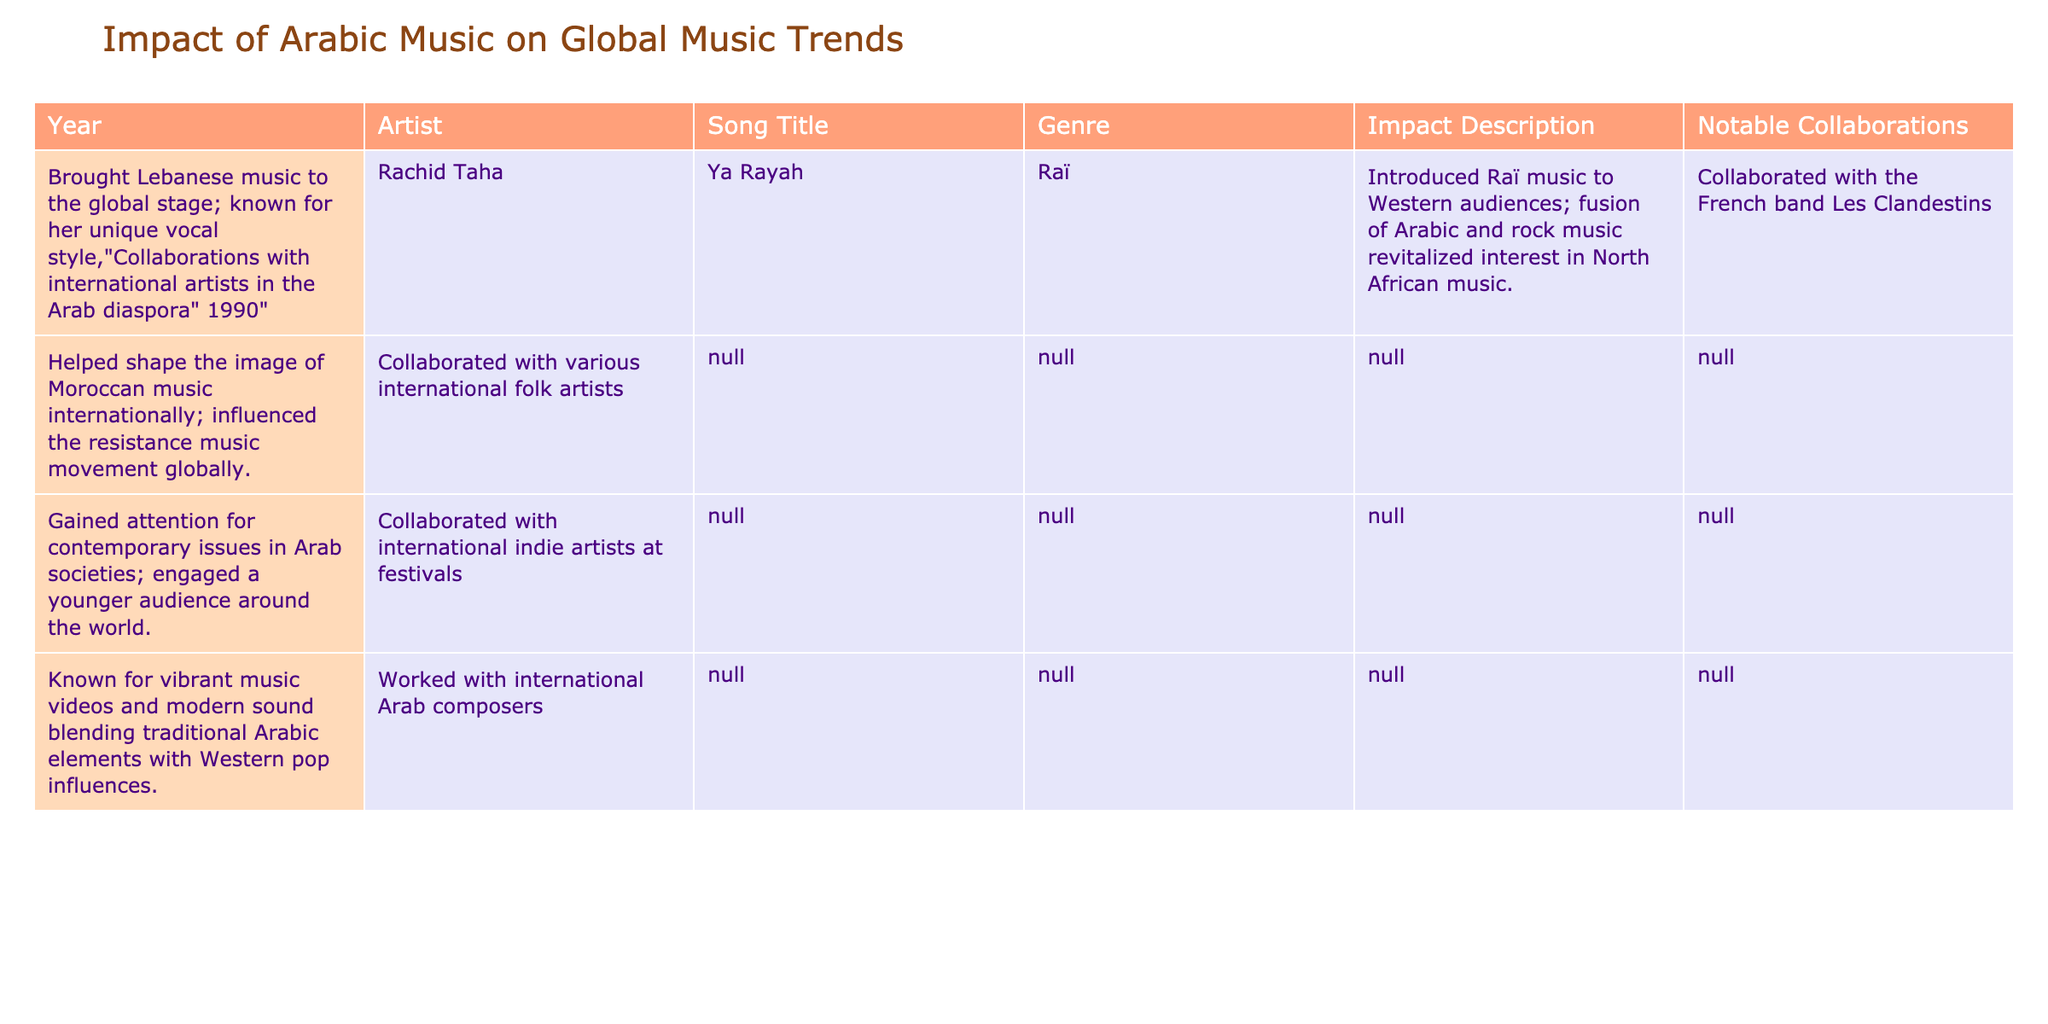What year did Fairuz release "Zarif El Fenn"? According to the table, the song "Zarif El Fenn" by Fairuz was released in the year 1970. The information is found directly in the "Year" column next to the artist and song title.
Answer: 1970 Which genre is Rachid Taha's "Ya Rayah"? The genre of the song "Ya Rayah" by Rachid Taha is categorized as Raï. This can be found in the "Genre" column associated with this song in the table.
Answer: Raï How many artists are mentioned in the table who collaborated with international artists? To find the answer, I will look at the "Notable Collaborations" column. The artists listed are Fairuz, Rachid Taha, Mashrou' Leila, and Balqis Fathi, all of whom had collaborations with international artists. That makes four artists.
Answer: 4 Did Nash El Ghiwane collaborate with international artists? The table indicates that Nass El Ghiwane collaborated with various international folk artists; therefore, the answer is yes. This is straightforward as it's mentioned directly in the "Notable Collaborations" column.
Answer: Yes What is the average year of release for the songs listed in the table? To calculate the average year, I'll sum all the years (1970 + 1990 + 2003 + 2015 + 2021 = 10099), and then divide by the number of songs, which is 5. The average year is 10099 / 5 = 2019.8. Rounding gives me 2020.
Answer: 2020 Which song had a notable impact on younger audiences? Mashrou' Leila's song "Cavalry" is noted for gaining attention for contemporary issues in Arab societies and engaging a younger audience worldwide. This specific impact is mentioned in the "Impact Description" column associated with this song.
Answer: Cavalry What was the impact of Balqis Fathi's music video style? The impact of Balqis Fathi’s music videos is described in terms of vibrancy and modern sound blending traditional Arabic elements with Western pop influences. This shows her innovation in the music video space.
Answer: Vibrant music videos blending Arabic and Western styles Which artist is associated with the resistance music movement? According to the table, Nass El Ghiwane's song "Proudly African" helped shape the image of Moroccan music internationally and influenced the resistance music movement globally. Thus, the associated artist is Nass El Ghiwane.
Answer: Nass El Ghiwane 